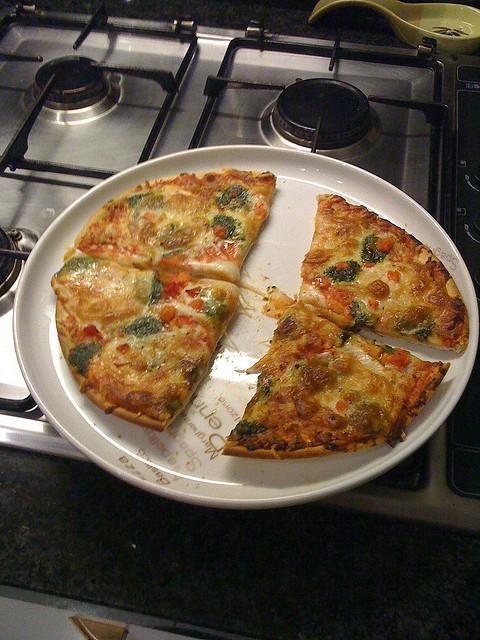How many slices are there on each pizza?
Give a very brief answer. 4. How many pizzas are there?
Give a very brief answer. 3. 